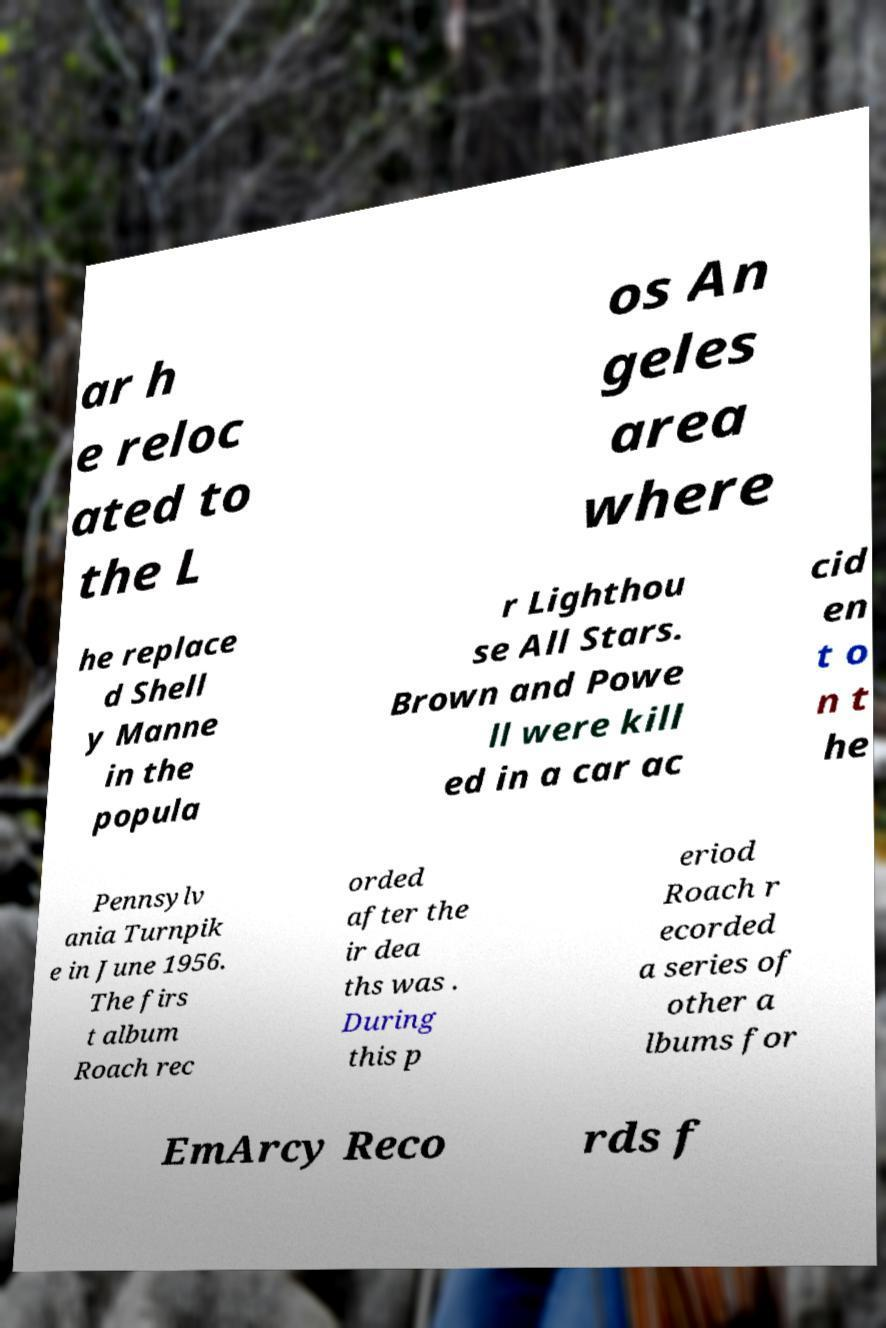Could you extract and type out the text from this image? ar h e reloc ated to the L os An geles area where he replace d Shell y Manne in the popula r Lighthou se All Stars. Brown and Powe ll were kill ed in a car ac cid en t o n t he Pennsylv ania Turnpik e in June 1956. The firs t album Roach rec orded after the ir dea ths was . During this p eriod Roach r ecorded a series of other a lbums for EmArcy Reco rds f 